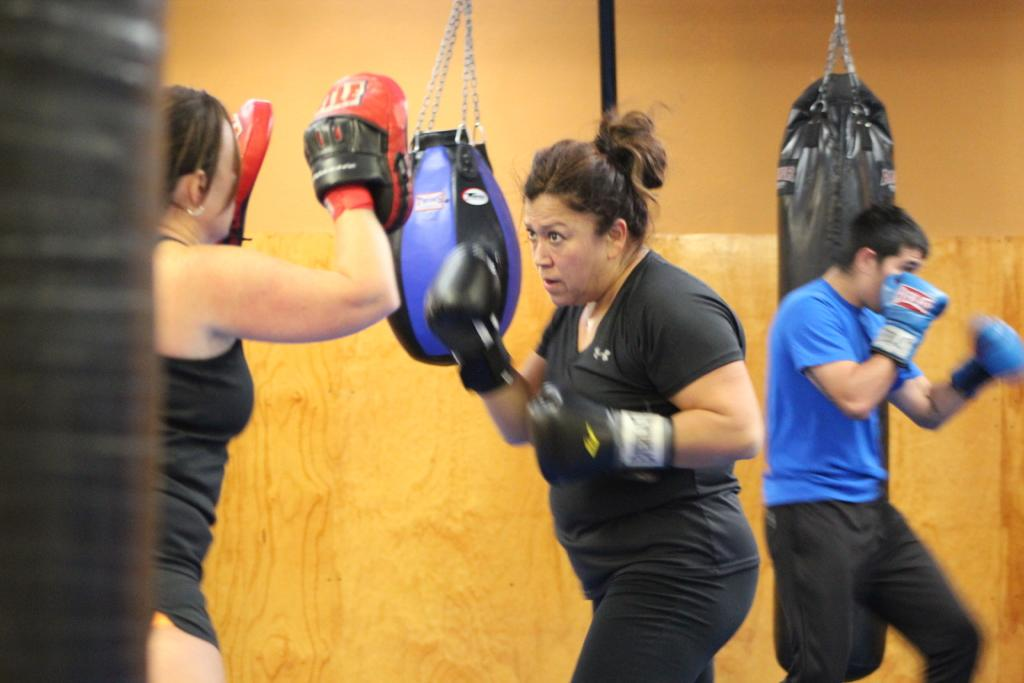How many people are present in the image? There are three people in the image. What are the people wearing on their hands? The three people are wearing gloves. Can you describe any objects in the image? There are objects in the image, but their specific nature is not mentioned in the facts. What can be seen in the background of the image? There are boxing bags and a wall visible in the background. What type of iron can be seen on the market map in the image? There is no iron, market, or map present in the image. 